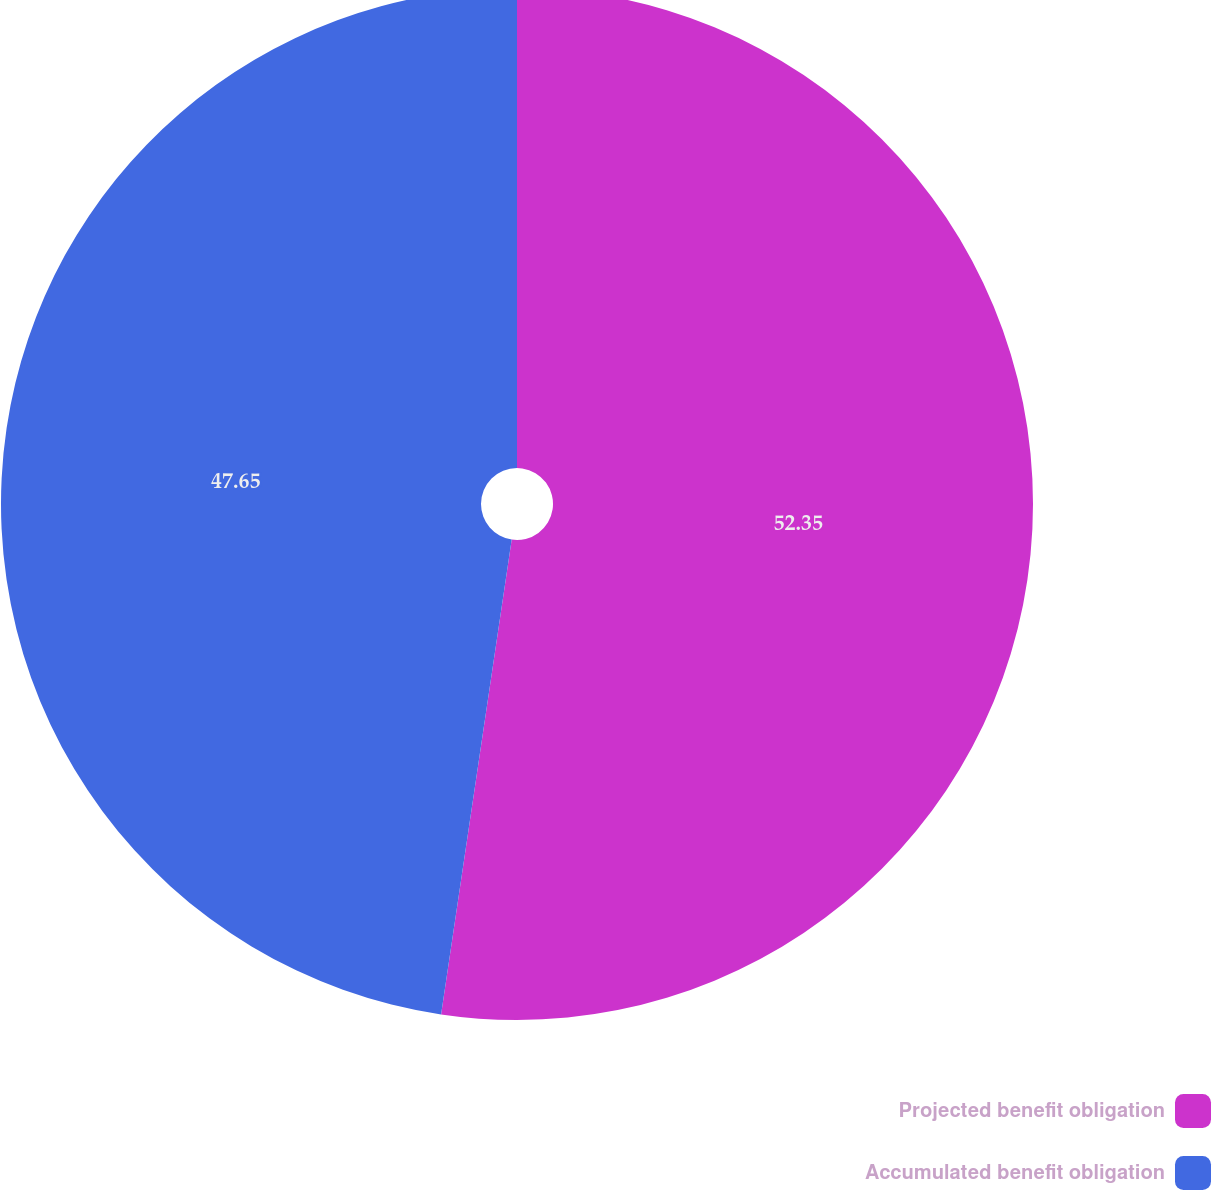<chart> <loc_0><loc_0><loc_500><loc_500><pie_chart><fcel>Projected benefit obligation<fcel>Accumulated benefit obligation<nl><fcel>52.35%<fcel>47.65%<nl></chart> 